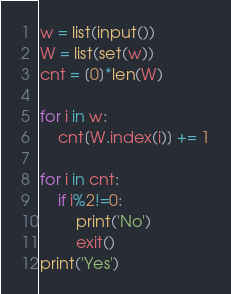Convert code to text. <code><loc_0><loc_0><loc_500><loc_500><_Python_>w = list(input())
W = list(set(w))
cnt = [0]*len(W)

for i in w:
    cnt[W.index(i)] += 1

for i in cnt:
    if i%2!=0:
        print('No')
        exit()
print('Yes')</code> 